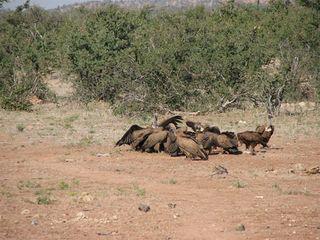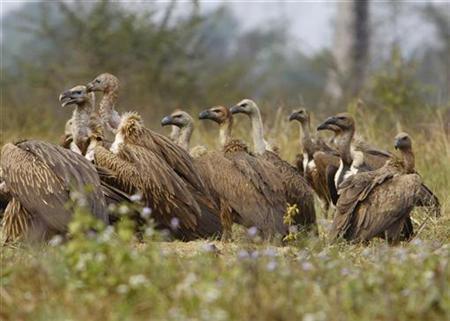The first image is the image on the left, the second image is the image on the right. Evaluate the accuracy of this statement regarding the images: "There are two kinds of bird in the image on the left.". Is it true? Answer yes or no. No. The first image is the image on the left, the second image is the image on the right. Examine the images to the left and right. Is the description "At least one image shows an apparently living mammal surrounded by vultures." accurate? Answer yes or no. No. 